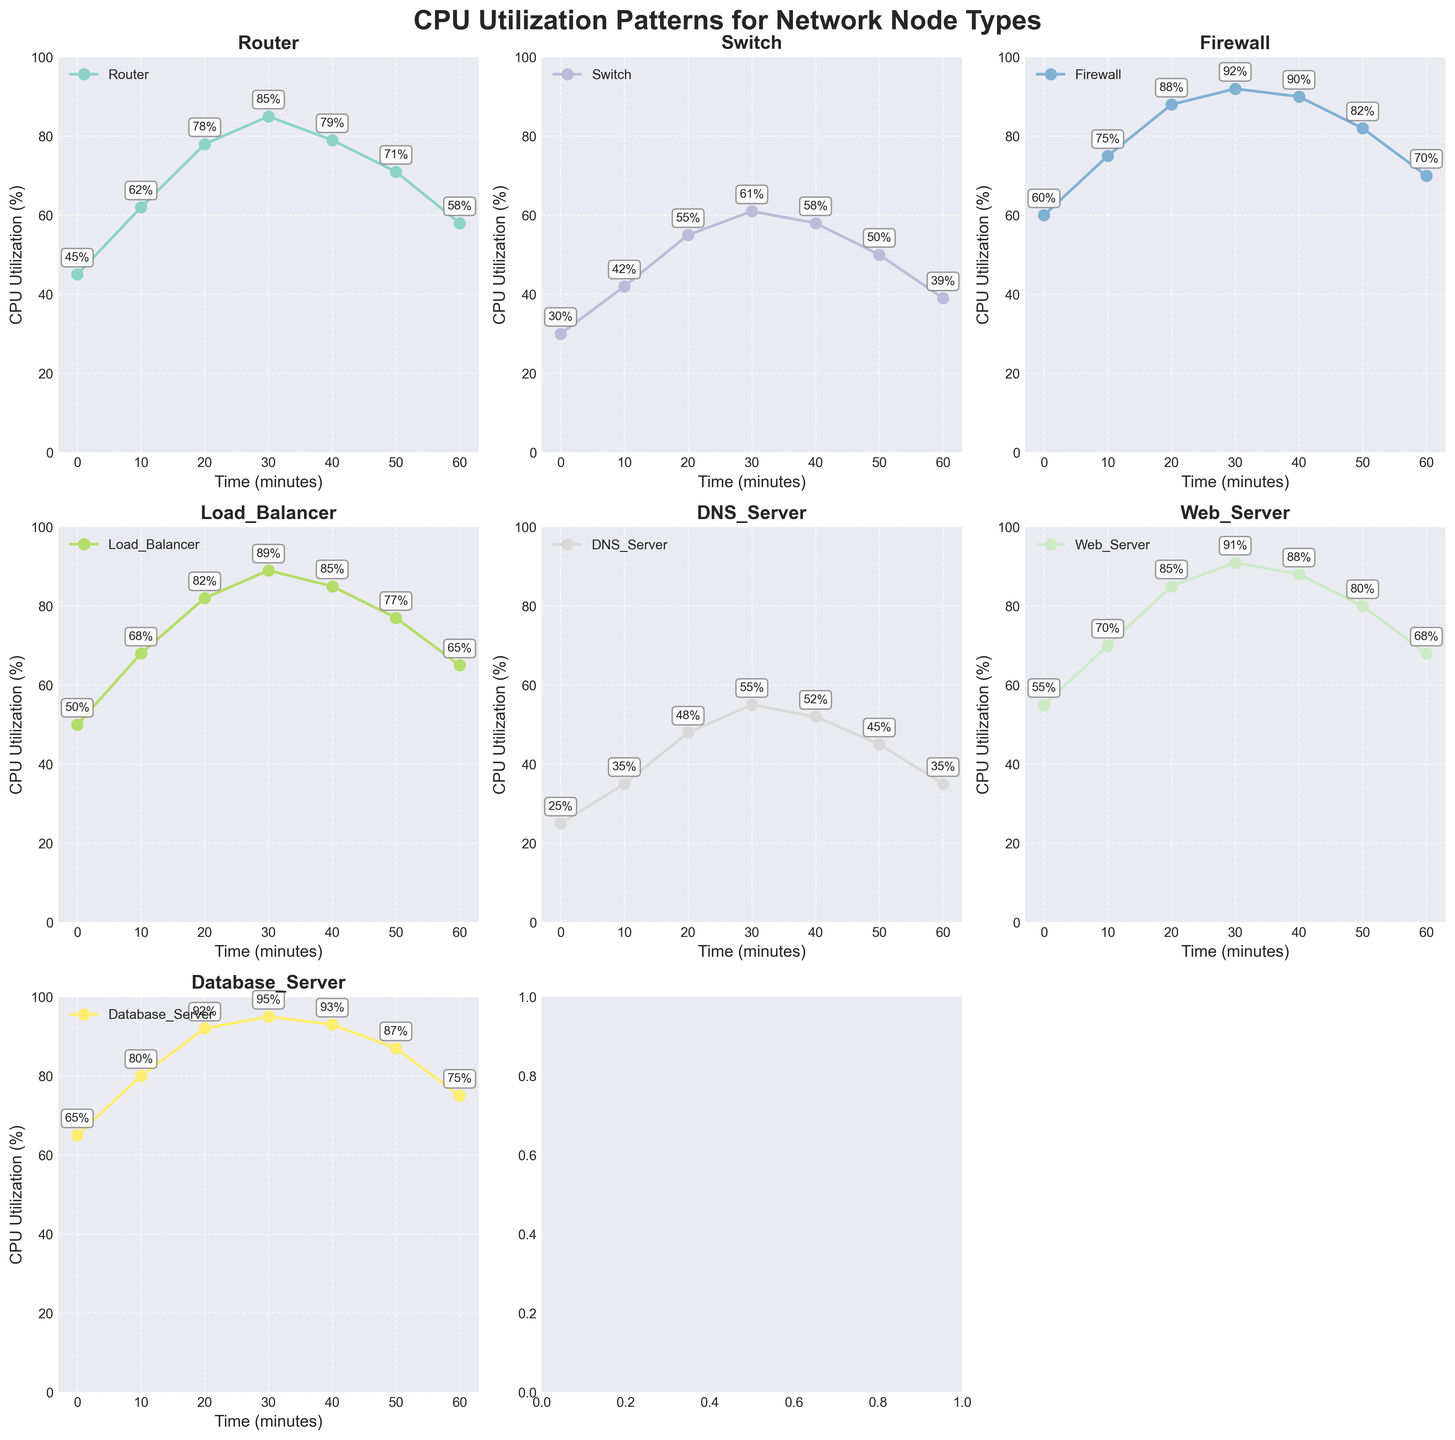What is the title of the figure? The title is prominently displayed at the top of the figure with a bold font style.
Answer: CPU Utilization Patterns for Network Node Types How many time points are used to measure CPU utilization? The x-axis of each subplot has ticks representing the time points, and there are seven labels: 0, 10, 20, 30, 40, 50, 60 minutes.
Answer: 7 Which network node type has the highest peak CPU utilization? By examining the highest y-value in each subplot, the 'Database_Server' shows a maximum CPU utilization of 95%.
Answer: Database_Server What is the average CPU utilization for the 'Router' over the time points? The CPU utilization values for 'Router' are 45, 62, 78, 85, 79, 71, and 58. The sum is 478, and the average is 478/7.
Answer: 68.29 During which time interval does the 'Firewall' node experience the highest rate of increase in CPU utilization? By analyzing the jumps between the time points for 'Firewall', the largest increase is from time 10 to time 20 with a jump from 75% to 88%.
Answer: 10 to 20 minutes What is the combined CPU utilization of 'Web_Server' and 'Load_Balancer' at time 30? At time 30, 'Web_Server' has a CPU utilization of 91% and 'Load_Balancer' has 89%. Their combined value is 91 + 89.
Answer: 180% Which node type shows the most significant drop in CPU utilization from peak to end point? By checking the differences between the peak value and the value at time 60 for each node, 'Firewall' drops from 92% to 70%.
Answer: Firewall Is there a node type that never exceeds 60% CPU utilization? 'DNS_Server' has values of 25, 35, 48, 55, 52, 45, and 35, all of which are below 60%.
Answer: Yes, DNS_Server How does the 'Switch' node's CPU utilization at time 40 compare to its value at time 60? The 'Switch' node has 58% CPU utilization at time 40 and 39% at time 60. It's a decrease by 19%.
Answer: 19% decrease 